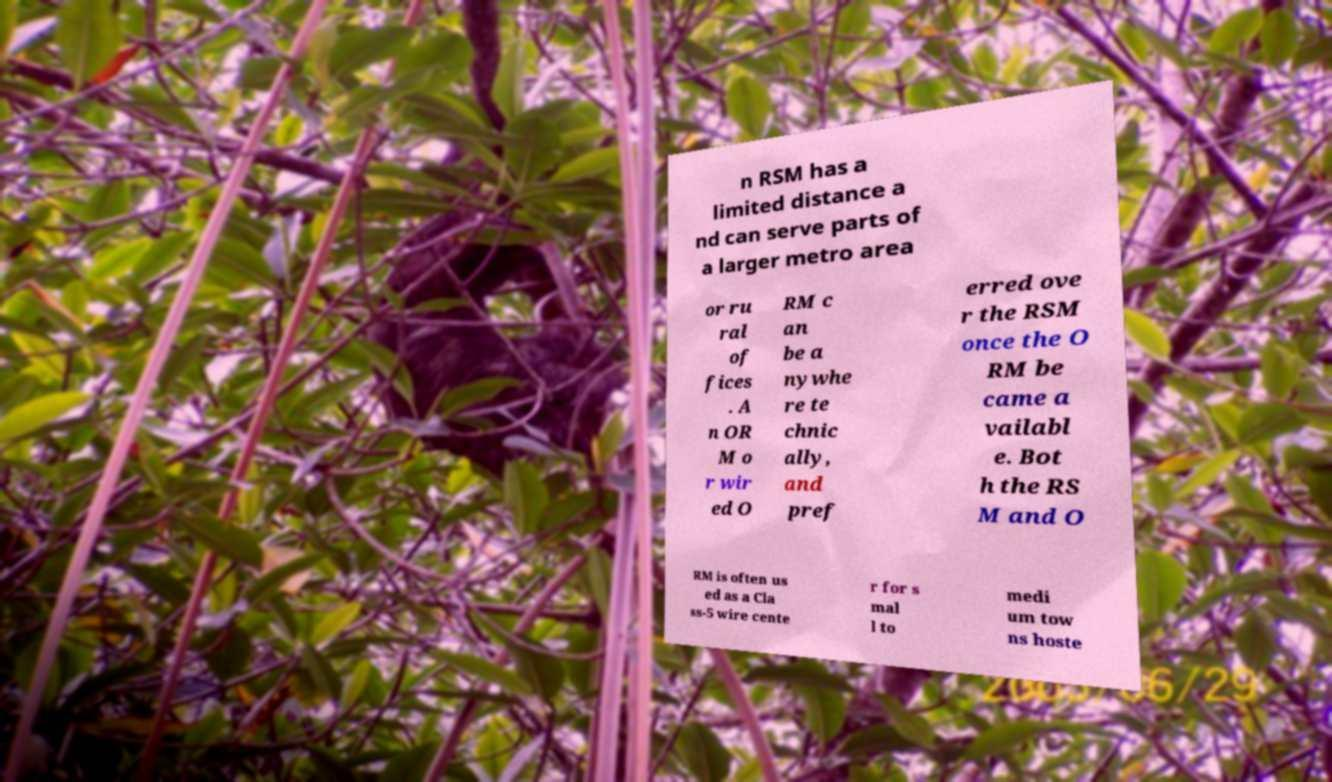Please read and relay the text visible in this image. What does it say? n RSM has a limited distance a nd can serve parts of a larger metro area or ru ral of fices . A n OR M o r wir ed O RM c an be a nywhe re te chnic ally, and pref erred ove r the RSM once the O RM be came a vailabl e. Bot h the RS M and O RM is often us ed as a Cla ss-5 wire cente r for s mal l to medi um tow ns hoste 